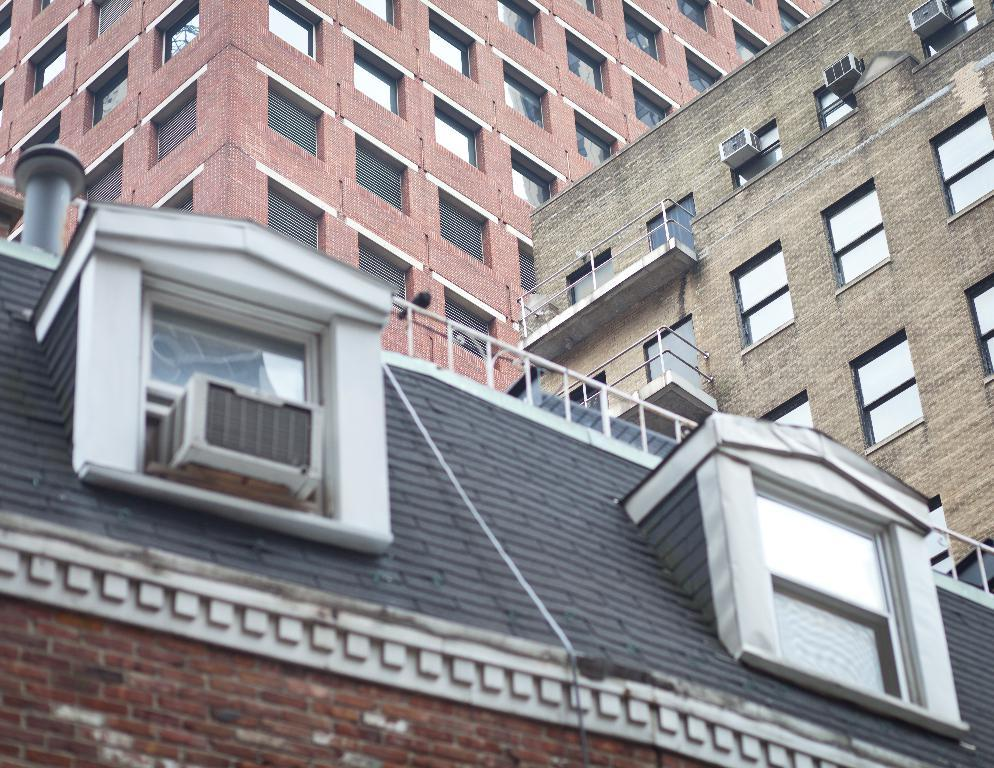What type of buildings can be seen in the image? There are buildings with glass windows in the image. What appliances are visible on the buildings? Air conditioners are visible in the image. What safety feature is present in the image? There is railing present in the image. What type of whip is being used to harvest the berries in the image? There are no whips or berries present in the image; it features buildings with glass windows, air conditioners, and railing. 